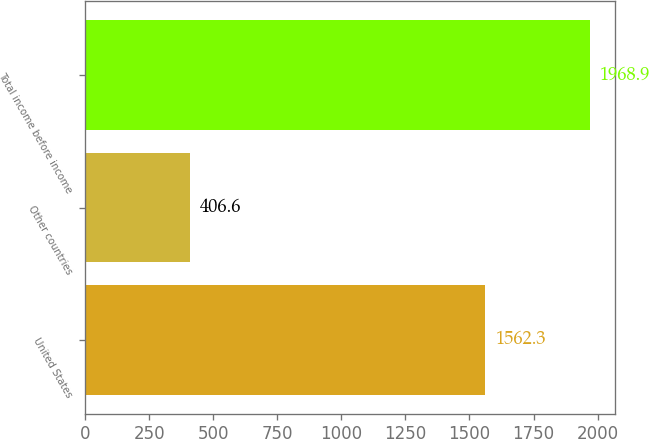<chart> <loc_0><loc_0><loc_500><loc_500><bar_chart><fcel>United States<fcel>Other countries<fcel>Total income before income<nl><fcel>1562.3<fcel>406.6<fcel>1968.9<nl></chart> 